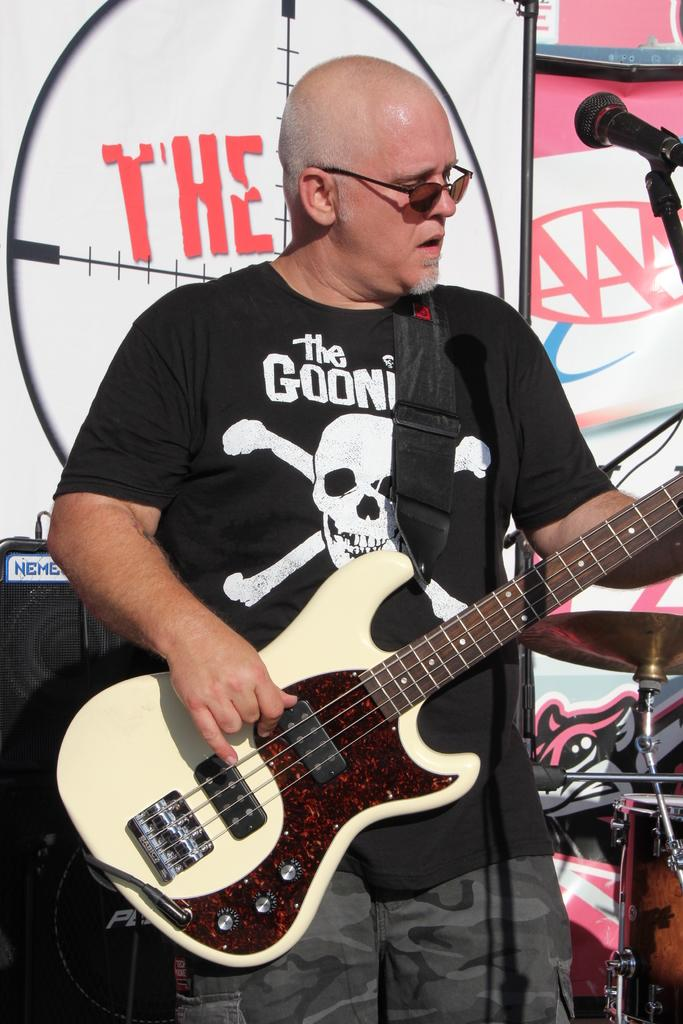Who is the main subject in the image? There is a man in the image. What is the man holding in the image? The man is holding a guitar. What object is in front of the man that might be used for amplifying his voice? There is a microphone with a stand in front of the man. What color is the plastic hand holding the guitar in the image? There is no plastic hand holding the guitar in the image; the man is holding the guitar with his own hands. 